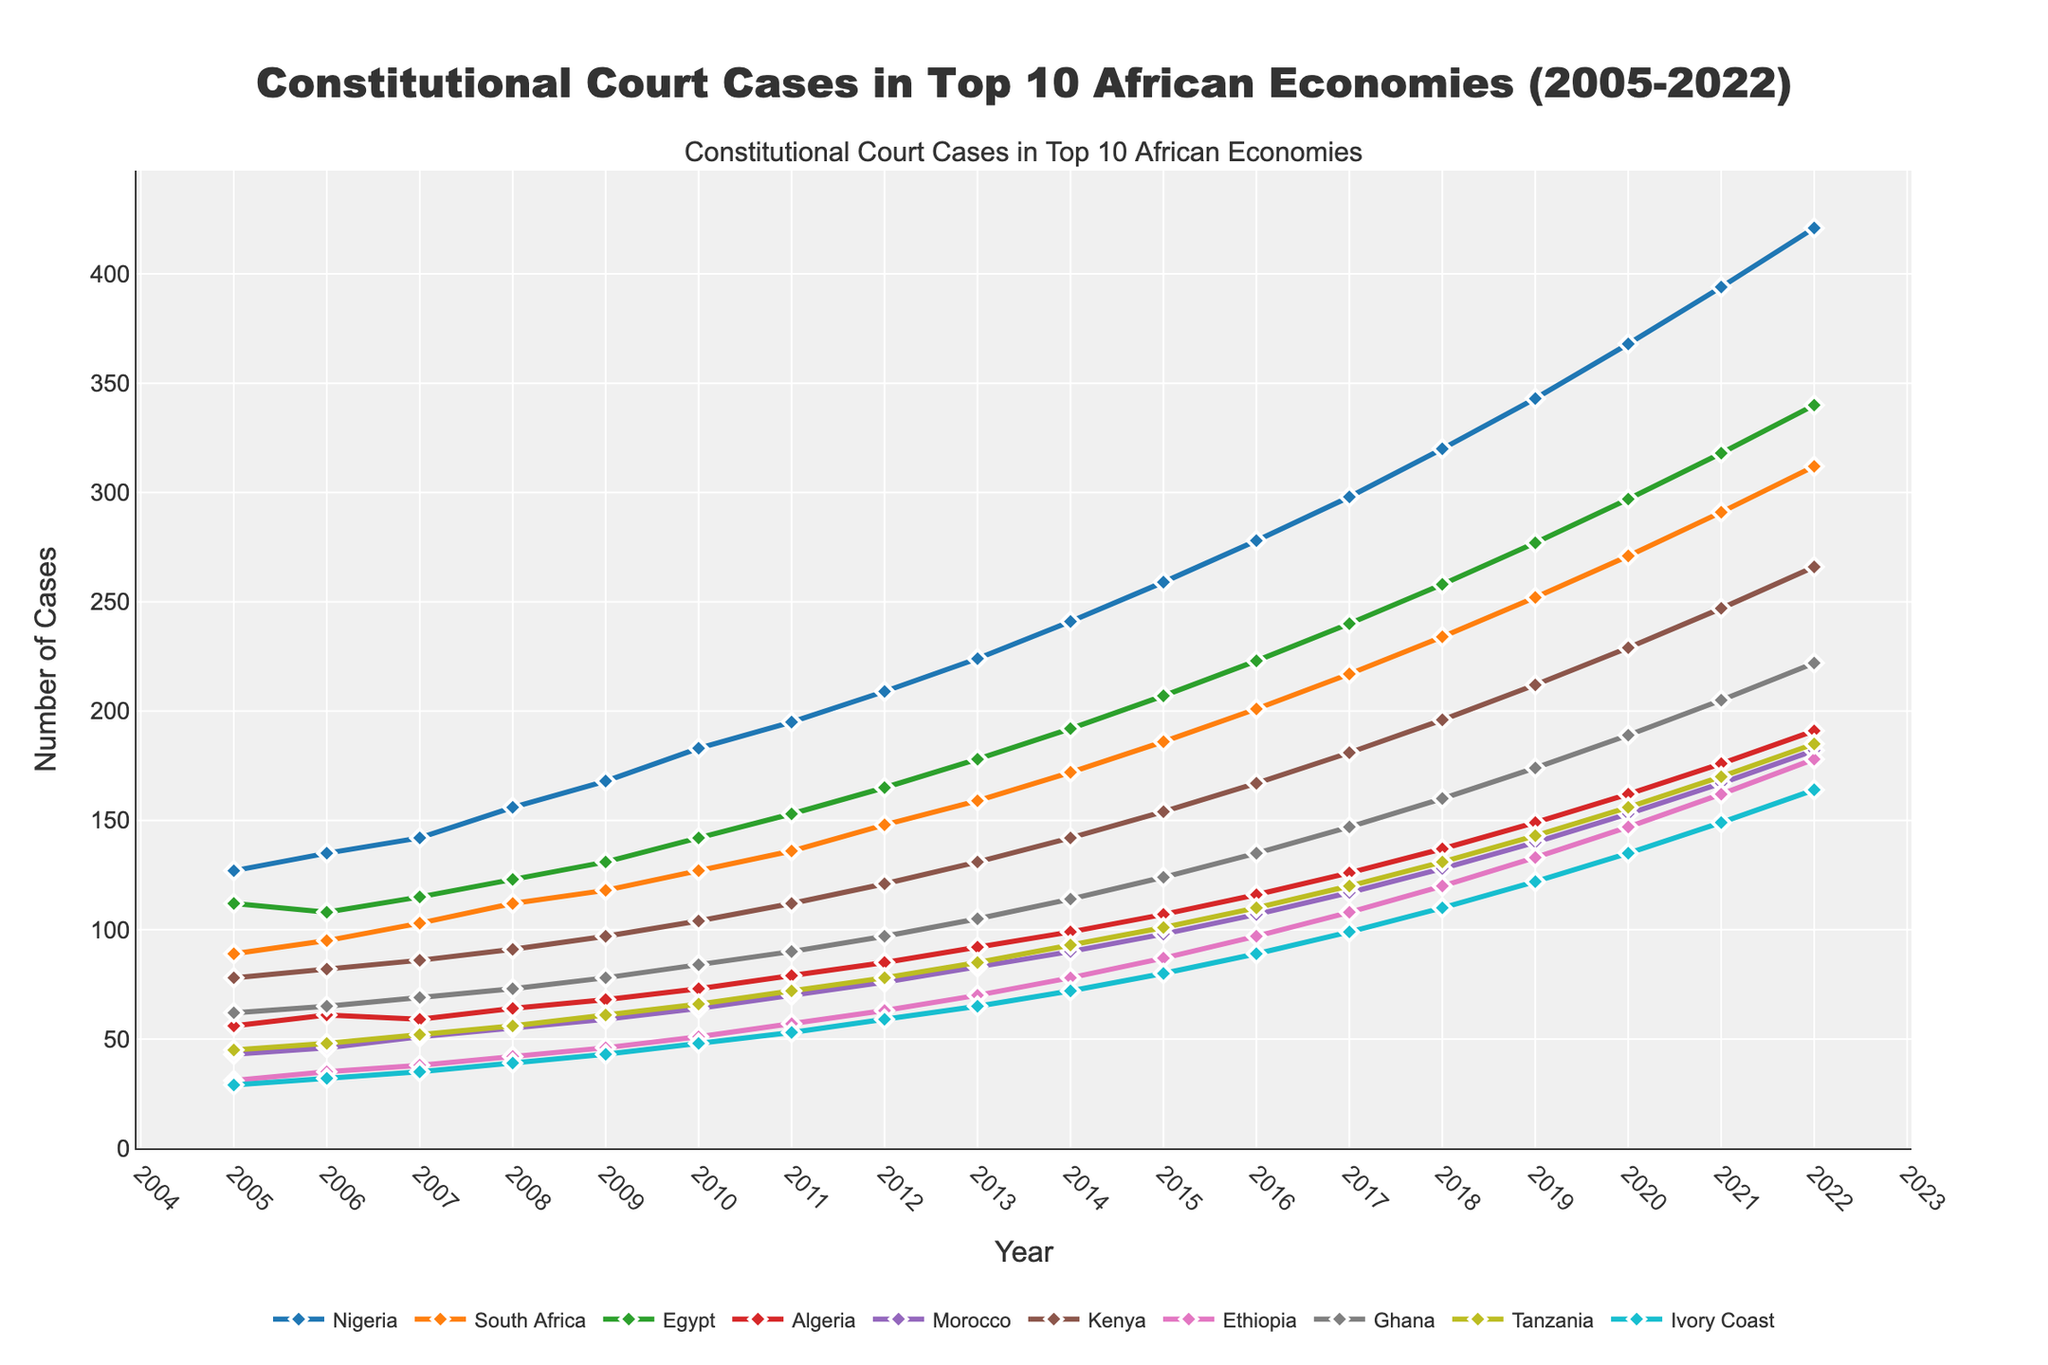What year did Nigeria have the highest number of constitutional court cases? To find this, look at the line for Nigeria, which is the topmost line, and identify the peak point in the timeline. The highest point for Nigeria is in 2022.
Answer: 2022 Which country had the second highest number of constitutional court cases in 2015? Locate the year 2015 in the x-axis, then compare the values for each country in that year. The second highest line after Nigeria in 2015 is South Africa.
Answer: South Africa By how much did the number of constitutional court cases in Kenya increase from 2005 to 2022? Identify Kenya's value in 2005 and 2022: 78 and 266 respectively. The increase is 266 - 78 = 188.
Answer: 188 Which country had the smallest increase in constitutional court cases from 2005 to 2022? Calculate the difference between values from 2005 and 2022 for each country, and identify the smallest difference. Ivory Coast has values of 29 in 2005 and 164 in 2022, which is an increase of 164 - 29 = 135, the smallest among all.
Answer: Ivory Coast What is the average number of constitutional court cases in South Africa over the given years? Summing up all values for South Africa from 2005 to 2022 gives 3261. There are 18 years, so the average is 3261 / 18 = 181.17.
Answer: 181.17 Which year did Ghana's number of constitutional court cases exceed 100 for the first time? Follow Ghana's line until it crosses the 100 mark. This first happens in 2015, with a value of 124.
Answer: 2015 Which country had consistently fewer cases than Ethiopia from 2005 to 2022? Compare the Ethiopia line with others. Ivory Coast's line is consistently below Ethiopia through all years.
Answer: Ivory Coast By how much did the number of cases in Nigeria increase between 2010 and 2015? For Nigeria, the number of cases in 2010 was 183 and in 2015 it was 259. The increase is 259 - 183 = 76.
Answer: 76 Which country showed the steepest increase in constitutional court cases from 2017 to 2018? Look at the slopes between 2017 and 2018 for all lines. Nigeria's line has the steepest slope, indicating the largest increase (320 - 298 = 22).
Answer: Nigeria Between 2008 and 2012, which country showed the most growth in the number of constitutional court cases? Calculate the difference between 2012 and 2008 values for all countries. Nigeria grew from 156 to 209, an increase of 53, which is the largest among all.
Answer: Nigeria 